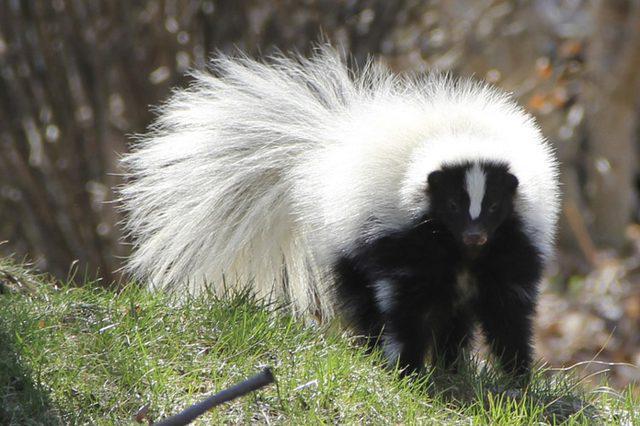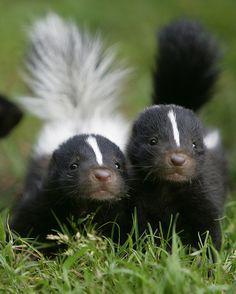The first image is the image on the left, the second image is the image on the right. Analyze the images presented: Is the assertion "The combined images include at least one erect skunk tail and at least one skunk facing forward." valid? Answer yes or no. Yes. The first image is the image on the left, the second image is the image on the right. Examine the images to the left and right. Is the description "there is a skunk peaking out from a fallen tree trunk with just the front part of it's bidy visible" accurate? Answer yes or no. No. 